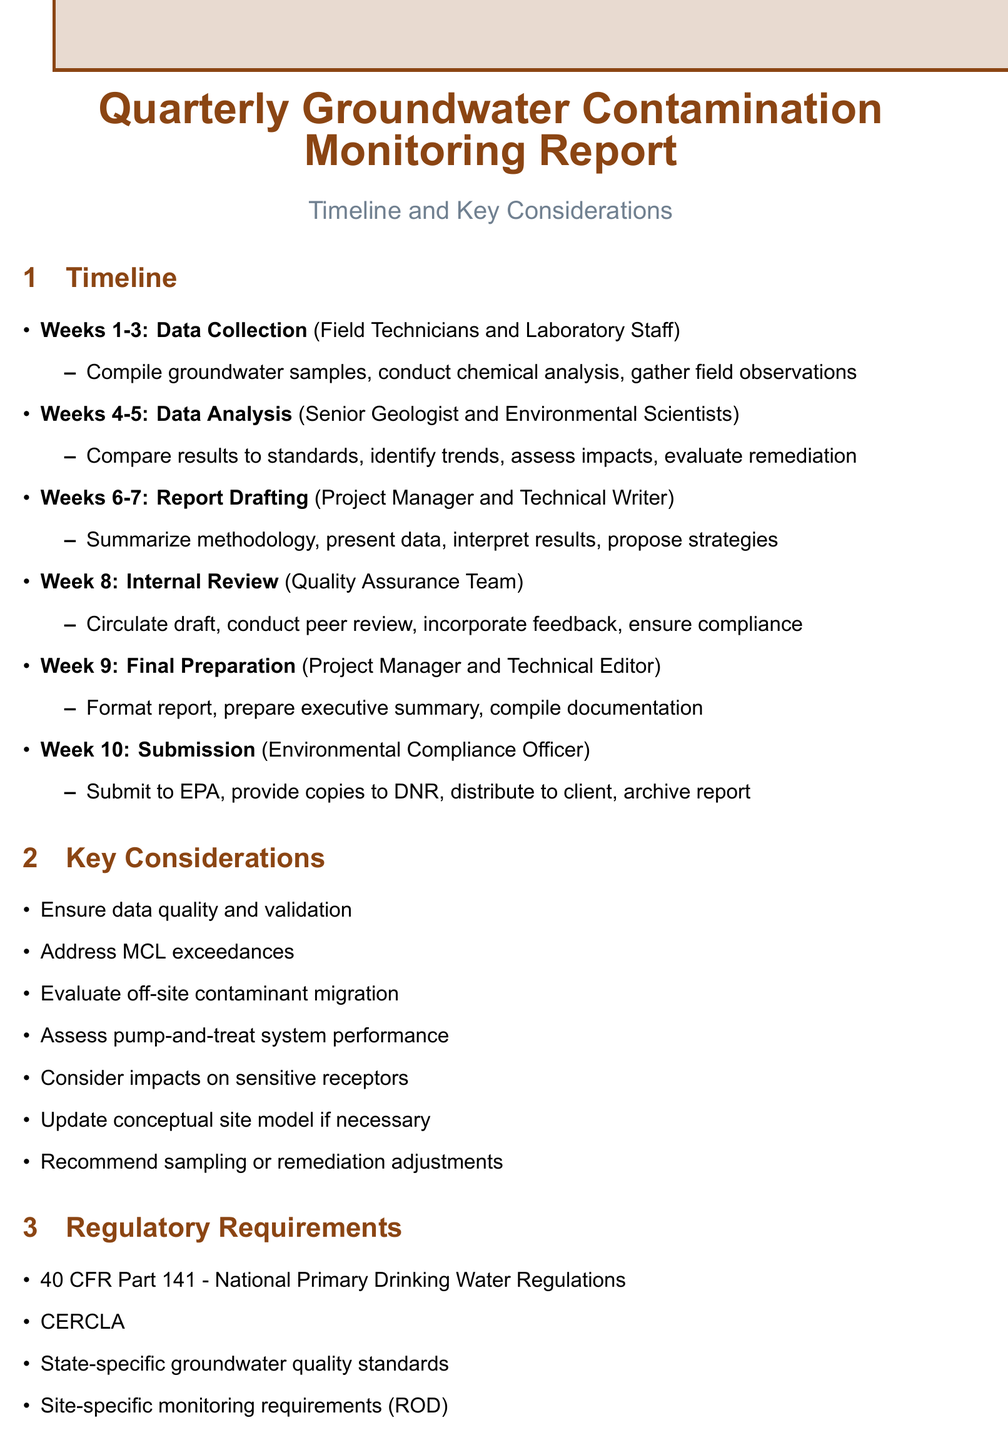what is the duration of the Data Collection phase? The duration is specified as Weeks 1-3 in the timeline.
Answer: Weeks 1-3 who is responsible for Data Analysis? The responsible parties for Data Analysis are listed as Senior Geologist and Environmental Scientists in the document.
Answer: Senior Geologist and Environmental Scientists what is one of the key considerations mentioned? A key consideration listed in the document is that data must be quality-checked and validated.
Answer: Ensure data quality and validation in which week does the Internal Review take place? The document clearly states that the Internal Review phase occurs in Week 8.
Answer: Week 8 what is the first task listed under Report Drafting? The first task under Report Drafting is summarizing methodology and sampling procedures.
Answer: Summarize methodology and sampling procedures which regulatory requirement is mentioned first? The first regulatory requirement listed in the document is 40 CFR Part 141 - National Primary Drinking Water Regulations.
Answer: 40 CFR Part 141 - National Primary Drinking Water Regulations who is the last person responsible for report submission? The document designates the Environmental Compliance Officer as the person responsible for report submission.
Answer: Environmental Compliance Officer what type of stakeholders are listed in the document? The stakeholders listed in the document include government agencies, the site owner, legal representation, and community groups.
Answer: U.S. Environmental Protection Agency, State Department of Natural Resources, Local Water Management District, Acme Manufacturing, Environmental Law Firm, Community Advisory Group 